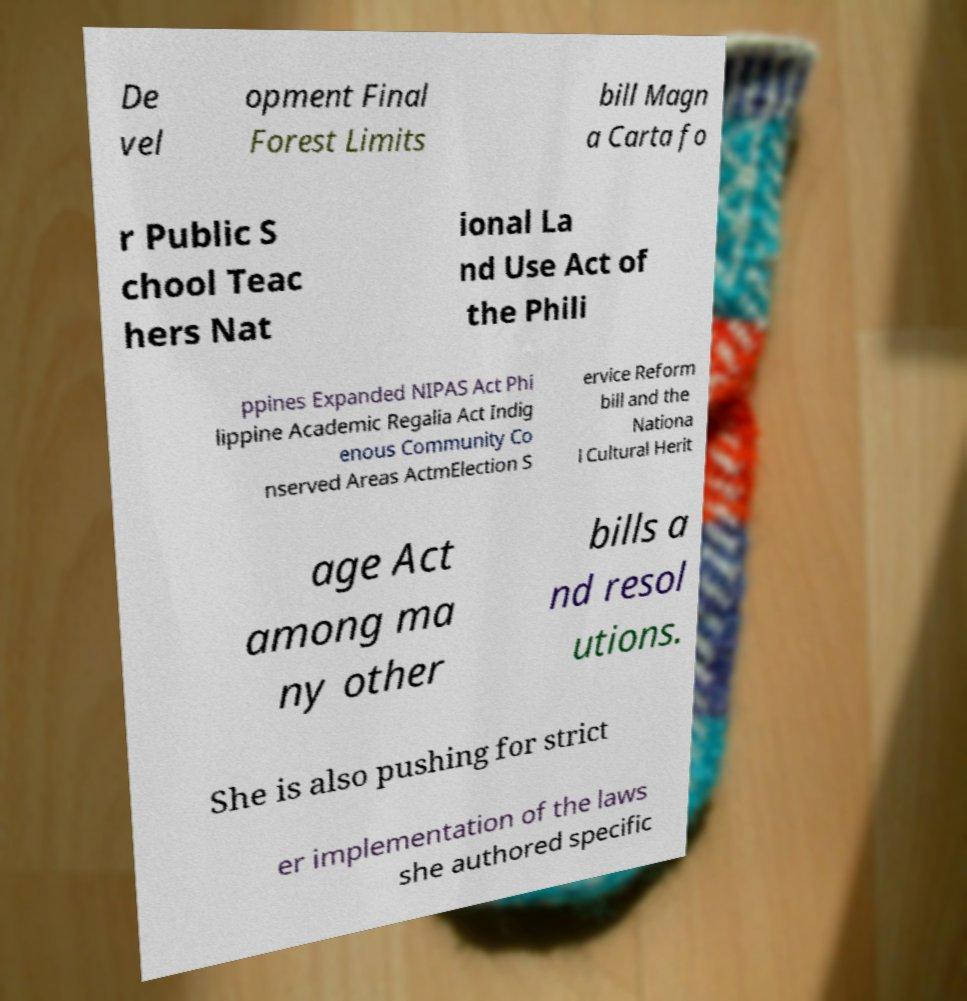What messages or text are displayed in this image? I need them in a readable, typed format. De vel opment Final Forest Limits bill Magn a Carta fo r Public S chool Teac hers Nat ional La nd Use Act of the Phili ppines Expanded NIPAS Act Phi lippine Academic Regalia Act Indig enous Community Co nserved Areas ActmElection S ervice Reform bill and the Nationa l Cultural Herit age Act among ma ny other bills a nd resol utions. She is also pushing for strict er implementation of the laws she authored specific 